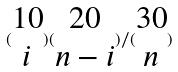<formula> <loc_0><loc_0><loc_500><loc_500>( \begin{matrix} 1 0 \\ i \end{matrix} ) ( \begin{matrix} 2 0 \\ n - i \end{matrix} ) / ( \begin{matrix} 3 0 \\ n \end{matrix} )</formula> 